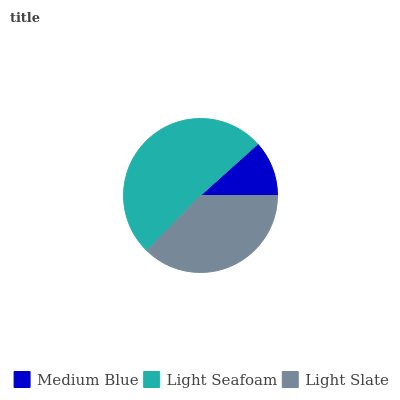Is Medium Blue the minimum?
Answer yes or no. Yes. Is Light Seafoam the maximum?
Answer yes or no. Yes. Is Light Slate the minimum?
Answer yes or no. No. Is Light Slate the maximum?
Answer yes or no. No. Is Light Seafoam greater than Light Slate?
Answer yes or no. Yes. Is Light Slate less than Light Seafoam?
Answer yes or no. Yes. Is Light Slate greater than Light Seafoam?
Answer yes or no. No. Is Light Seafoam less than Light Slate?
Answer yes or no. No. Is Light Slate the high median?
Answer yes or no. Yes. Is Light Slate the low median?
Answer yes or no. Yes. Is Medium Blue the high median?
Answer yes or no. No. Is Light Seafoam the low median?
Answer yes or no. No. 